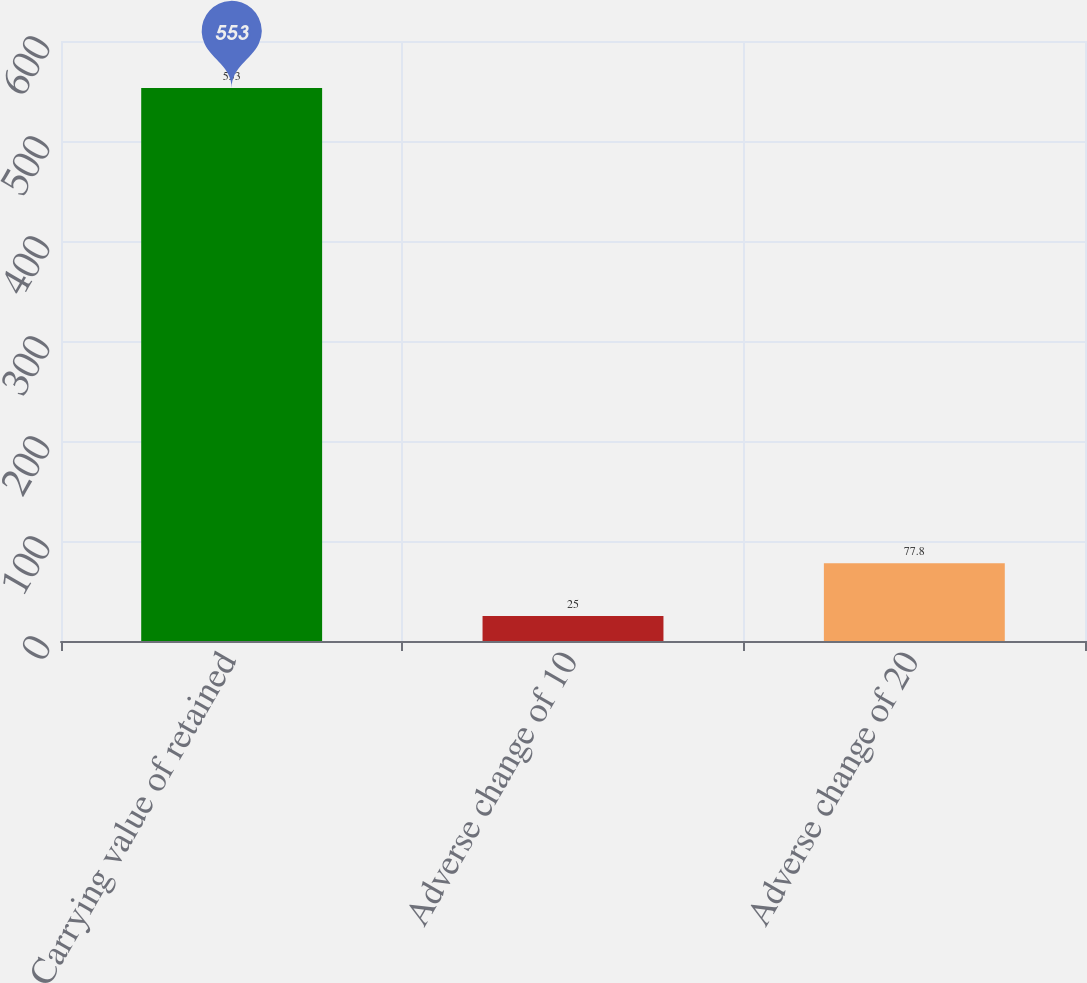Convert chart to OTSL. <chart><loc_0><loc_0><loc_500><loc_500><bar_chart><fcel>Carrying value of retained<fcel>Adverse change of 10<fcel>Adverse change of 20<nl><fcel>553<fcel>25<fcel>77.8<nl></chart> 